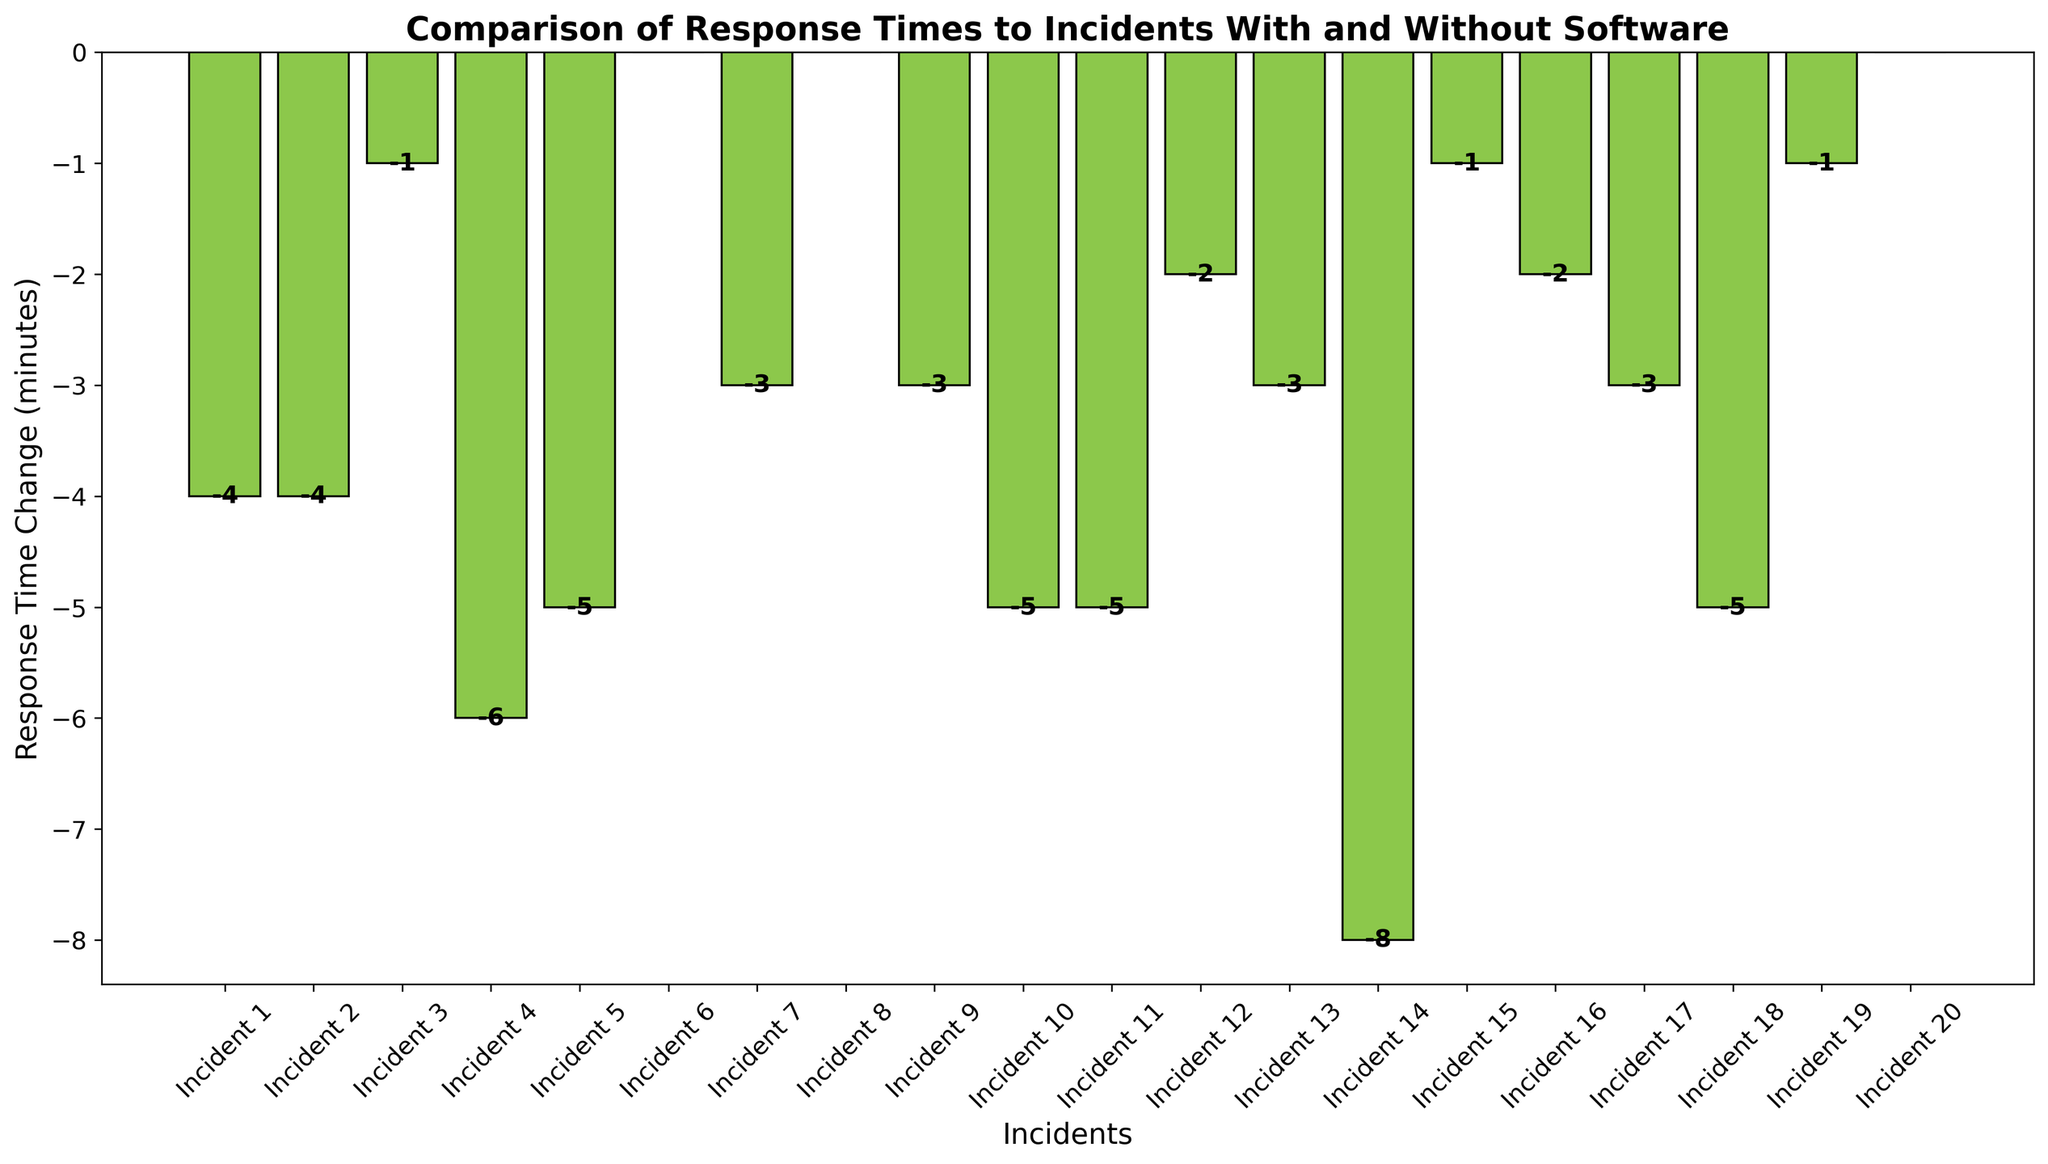Which incident shows the greatest reduction in response time? The bar chart shows negative values for the reduction in response time. The incident with the greatest negative value indicates the largest reduction in response time. Incident 14 has the highest reduction with a value of -8.
Answer: Incident 14 Which incidents have no change in response time with the software? No change in response time is indicated by bars with a height of zero. By observing the chart, Incidents 6, 8, and 20 show no change in response time with the software.
Answer: Incidents 6, 8, and 20 What is the total reduction in response time for all incidents combined? To get the total reduction in response time, sum all negative values and the zeros. The values are -4, -4, -1, -6, -5, -3, -3, -5, -5, -2, -3, -8, -1, -2, -3, -5, -1, and 0 (incident 6, 8, and 20 are zero). Sum = -63.
Answer: -63 How many incidents had a reduced response time greater than or equal to 5 minutes? Identify the bars with values less than or equal to -5 (indicating the reduction) and count them. The incidents are Incident 4, Incident 5, Incident 10, Incident 11, Incident 14, and Incident 18. The count is 6.
Answer: 6 Which incident had the smallest reduction in response time? The smallest reduction is identified by the smallest (closest to zero) negative value. Incident 3 and Incident 15 both have a response time change of -1, which is the smallest reduction.
Answer: Incident 3 and Incident 15 What is the average reduction in response time across all incidents? To calculate the average reduction, sum all values in the "Response Time Change" column and divide by the number of incidents (20). Sum = -63, Number of incidents = 20, Average = -63/20 = -3.15.
Answer: -3.15 Compare the response time change for Incident 7 and Incident 17. Which had a greater reduction? Incident 7 has a response time change of -3, and Incident 17 also has -3. Both incidents had the same reduction in response time.
Answer: Same reduction What percentage of incidents saw a reduction in response time? Count the number of incidents with a negative value and divide by the total number of incidents, then multiply by 100. Out of 20 incidents, 17 had reduced response times. Calculation: (17/20) * 100 = 85%.
Answer: 85% Which incident shows the largest positive change in response time (if any)? Positive change would be indicated by positive bars. Since all bars are either negative or zero, no incident shows a positive change.
Answer: None What is the median reduction in response time? To find the median, list all response time changes in order and find the middle value. Ordered values: -8, -6, -5, -5, -5, -5, -4, -4, -3, -3, -3, -3, -2, -2, -1, -1, -1, 0, 0, 0. The median value (middle of ordered list) is -3.
Answer: -3 